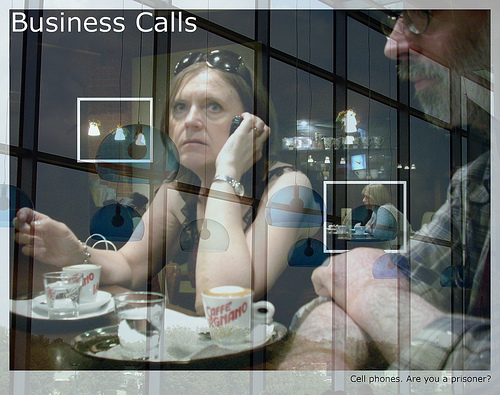In which part of the picture is the coffee cup, the top or the bottom? The coffee cup is in the bottom part of the picture. 